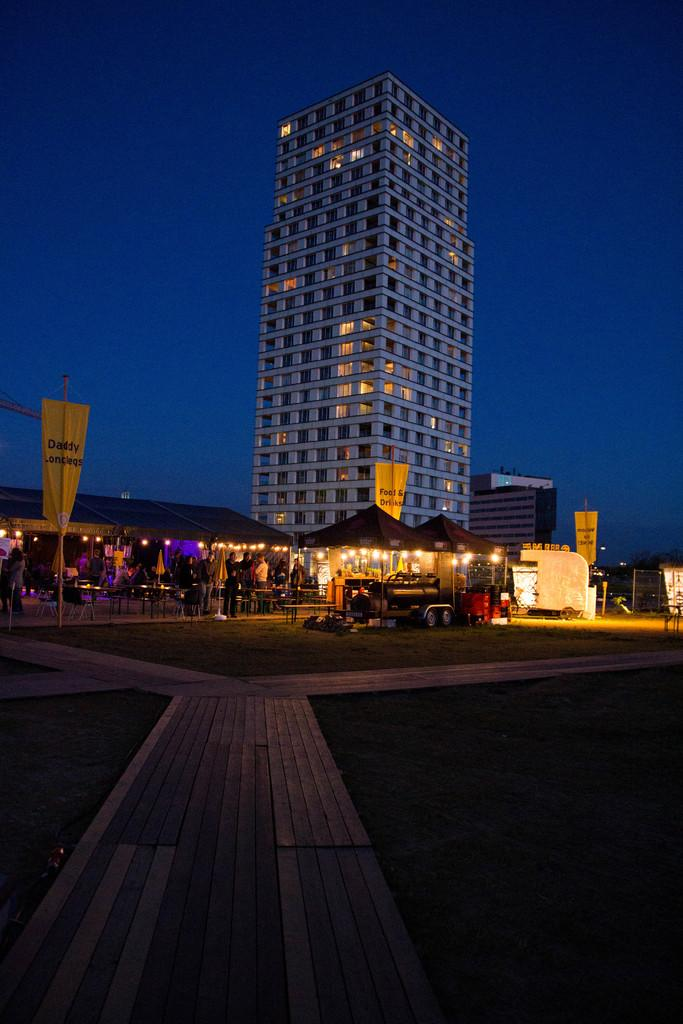What type of structures can be seen in the image? There are buildings in the image. What temporary shelters are present in the image? There are tents in the image. What mode of transportation is visible in the image? A vehicle is visible in the image. What illuminates the scene in the image? Lights are present in the image. Who is present in the image? There are people in the image. What colorful objects can be seen in the image? Yellow color flags are in the image. What is the color of the sky in the image? The sky is blue in color. How many firemen are present in the image? There is no mention of firemen in the image, so we cannot determine their presence or number. What type of women can be seen in the image? There is no mention of women in the image, so we cannot determine their presence or characteristics. 